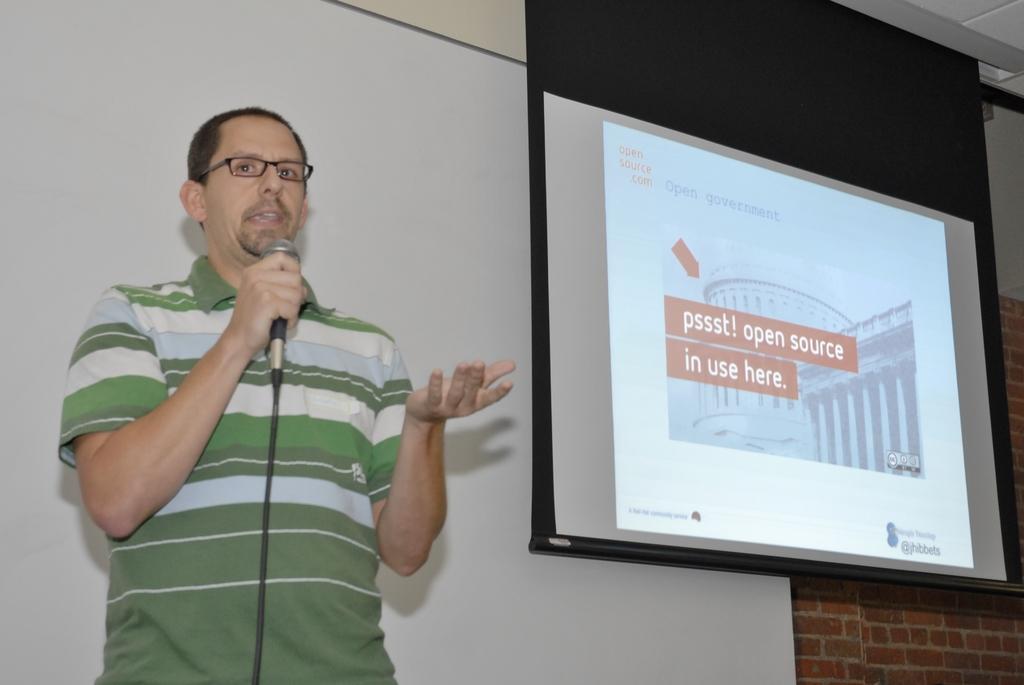Can you describe this image briefly? In this image there is a man who is wearing the spectacles is holding the mic. On the right side there is a projector. In the background there is a wall. On the left side there is a board in the background. 